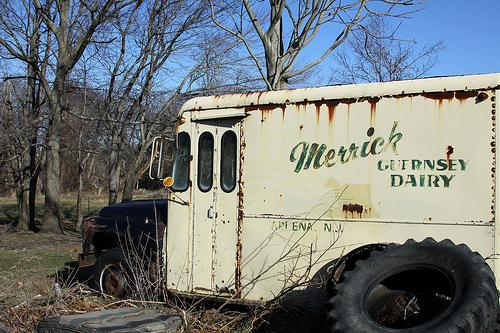Describe the condition and location of the tire seen in the image. There is an old, large tire leaning against the old dairy truck, which is located on its side near the back of the vehicle. Describe the general condition of the trees in the background of the image. The trees in the background are deciduous with no leaves, some have long branches, and a tree trunk is visible. List the main focal points of the image. old dairy truck, rust, green writing, cow shape, old tire leaning, wooded environment, orange reflector, and large grey rock Identify the type of vehicle depicted in the image and give a brief description of its appearance. An old dairy truck with rust, green writing on the side, cow shape design, and black paint on the front is sitting in a wooded area with an old tire leaning against it. What is the condition of the surrounding environment in the image? The environment consists of deciduous trees with no foliage, a large grey rock by the truck, and weeds growing near the old truck. Mention any interesting objects that are adjacent to the vehicle in the image. An old tire leaning on the truck, a large grey rock, dead branches beside the truck, and old gray cushion on the ground can be seen adjacent to the vehicle. What can you infer about the vehicle's current state based on its appearance in the image? The old dairy truck appears to be abandoned and not in working condition due to the rust, decay, and being surrounded by overgrowth. Describe any unique features of the vehicle in the picture. The old dairy truck has green writing on the side, cow shape on it, rust on top, and black paint on the front, and is abandoned near woods. Point out any notable objects or accessories on the vehicle. The old dairy truck has an orange reflector, doors with windows, and driver side mirrors as notable accessories. Provide a detailed description of the text and logos found on the truck. The truck has green writing on its side, which appears faded, and a green logo, indicating that it might have been a dairy truck with branding. 